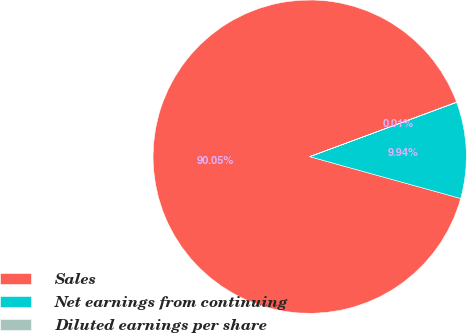<chart> <loc_0><loc_0><loc_500><loc_500><pie_chart><fcel>Sales<fcel>Net earnings from continuing<fcel>Diluted earnings per share<nl><fcel>90.05%<fcel>9.94%<fcel>0.01%<nl></chart> 